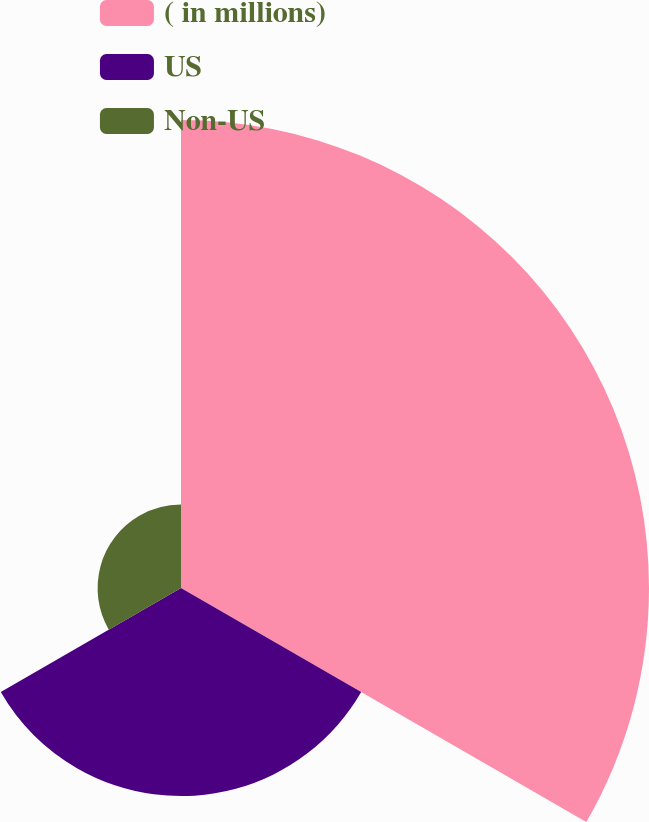Convert chart. <chart><loc_0><loc_0><loc_500><loc_500><pie_chart><fcel>( in millions)<fcel>US<fcel>Non-US<nl><fcel>61.62%<fcel>27.4%<fcel>10.98%<nl></chart> 